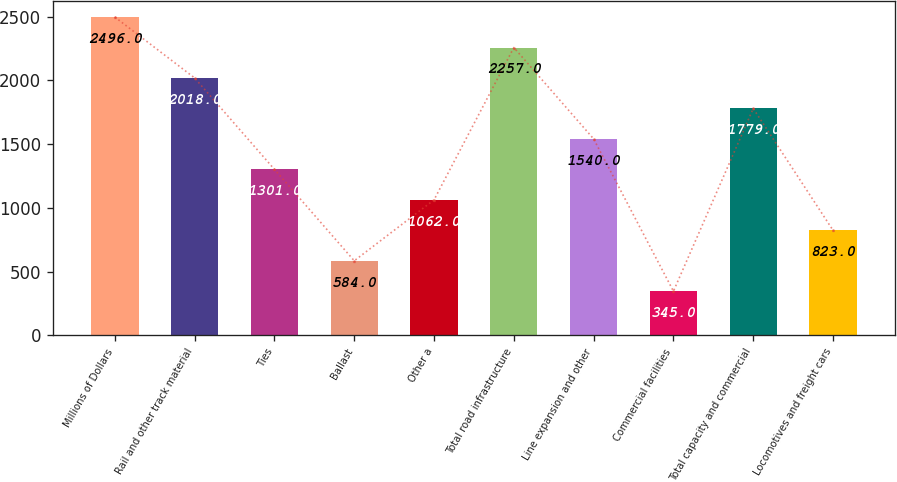Convert chart to OTSL. <chart><loc_0><loc_0><loc_500><loc_500><bar_chart><fcel>Millions of Dollars<fcel>Rail and other track material<fcel>Ties<fcel>Ballast<fcel>Other a<fcel>Total road infrastructure<fcel>Line expansion and other<fcel>Commercial facilities<fcel>Total capacity and commercial<fcel>Locomotives and freight cars<nl><fcel>2496<fcel>2018<fcel>1301<fcel>584<fcel>1062<fcel>2257<fcel>1540<fcel>345<fcel>1779<fcel>823<nl></chart> 